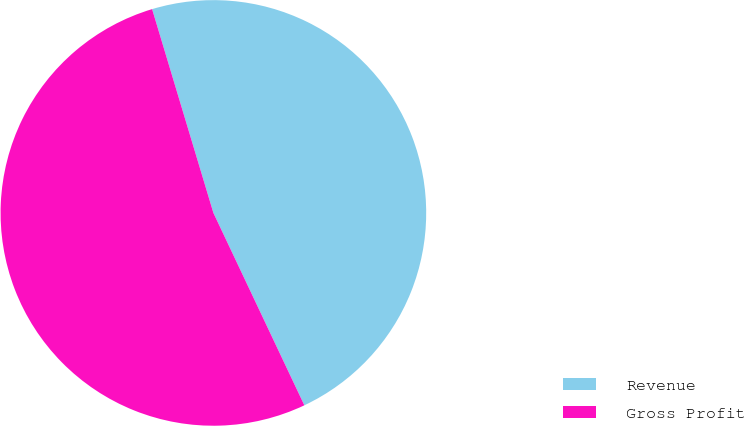<chart> <loc_0><loc_0><loc_500><loc_500><pie_chart><fcel>Revenue<fcel>Gross Profit<nl><fcel>47.62%<fcel>52.38%<nl></chart> 